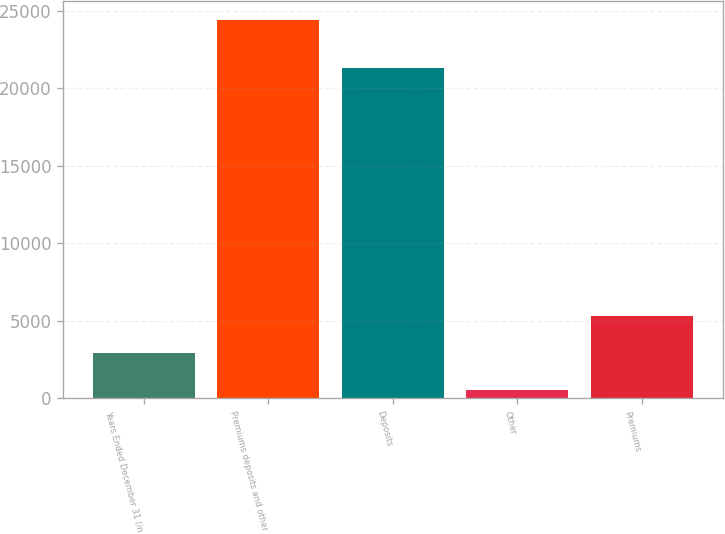Convert chart to OTSL. <chart><loc_0><loc_0><loc_500><loc_500><bar_chart><fcel>Years Ended December 31 (in<fcel>Premiums deposits and other<fcel>Deposits<fcel>Other<fcel>Premiums<nl><fcel>2926.1<fcel>24392<fcel>21338<fcel>541<fcel>5311.2<nl></chart> 